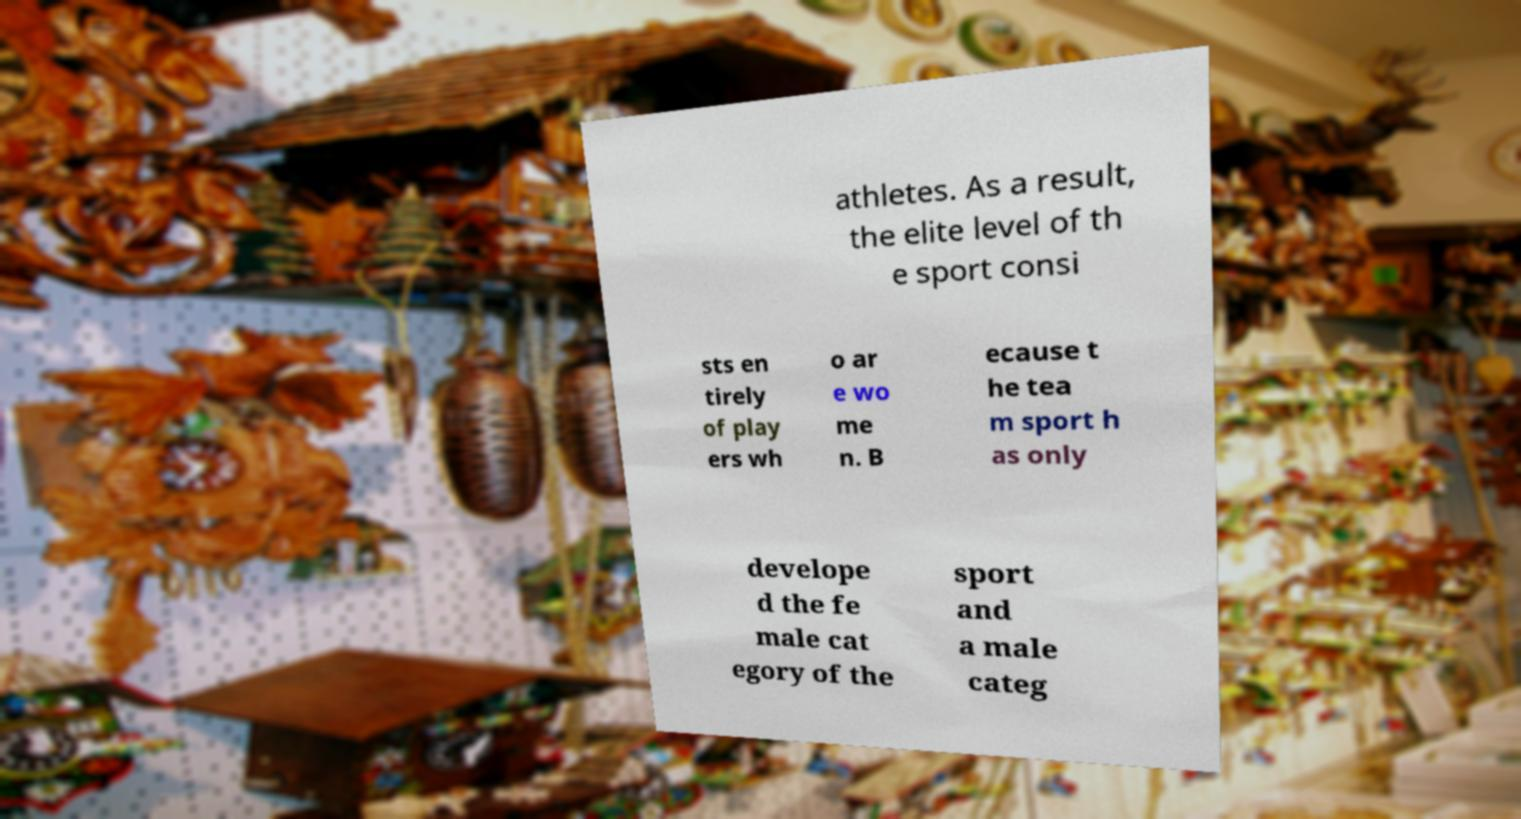Could you assist in decoding the text presented in this image and type it out clearly? athletes. As a result, the elite level of th e sport consi sts en tirely of play ers wh o ar e wo me n. B ecause t he tea m sport h as only develope d the fe male cat egory of the sport and a male categ 